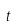<formula> <loc_0><loc_0><loc_500><loc_500>t</formula> 